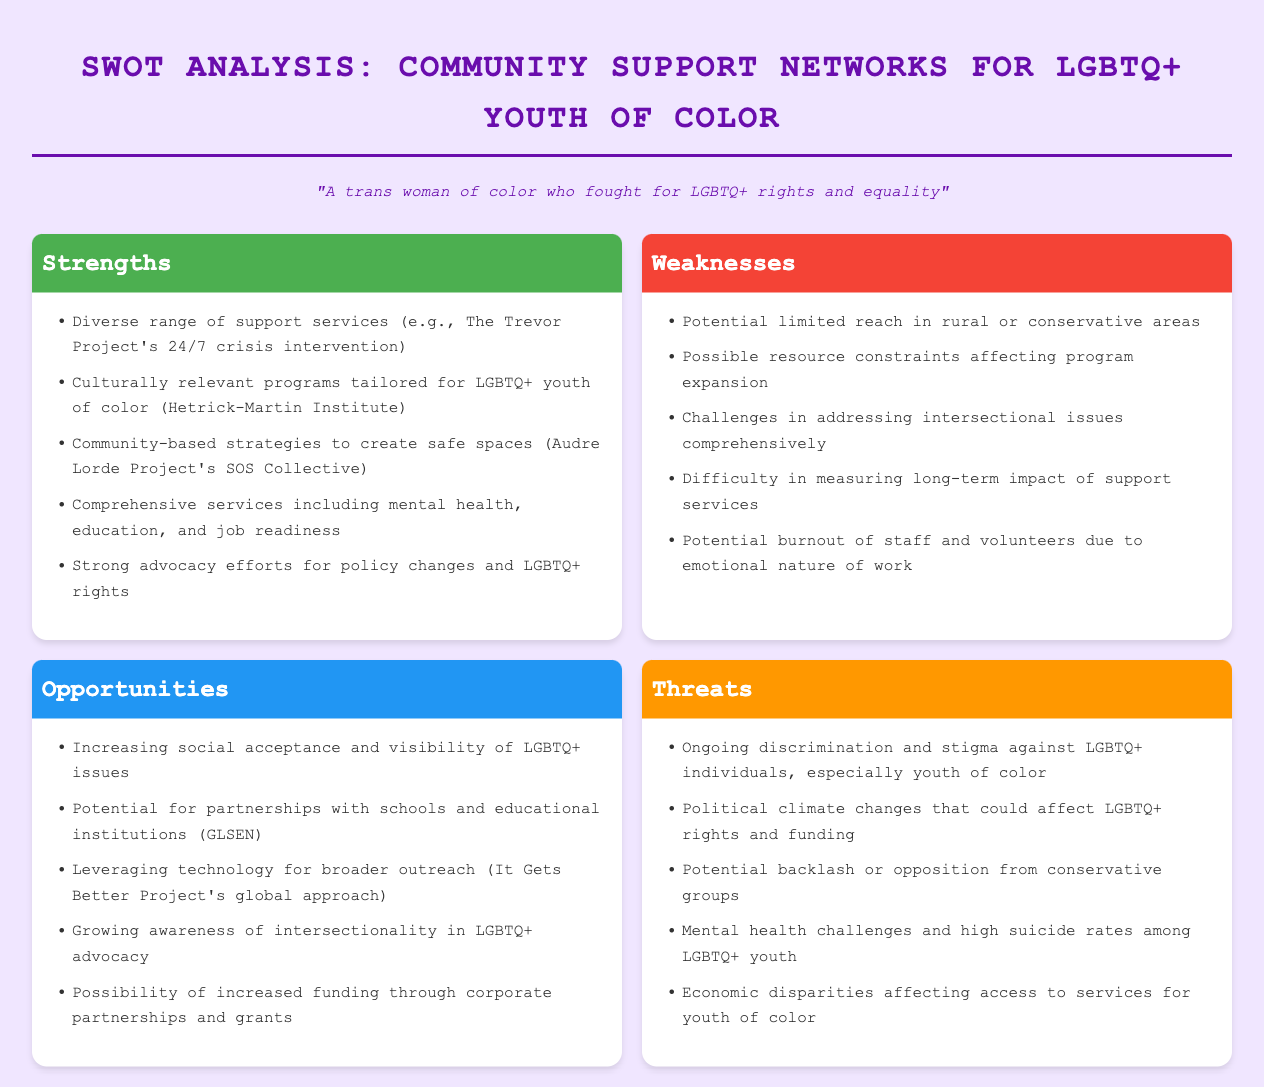What are some strengths of the community support networks? The strengths are outlined in the "Strengths" section and include diverse support services, culturally relevant programs, community-based strategies, comprehensive services, and strong advocacy efforts.
Answer: Diverse range of support services, culturally relevant programs, community-based strategies, comprehensive services, strong advocacy efforts What is a weakness related to program expansion? The weakness that affects program expansion can be found in the "Weaknesses" section, which mentions resource constraints.
Answer: Possible resource constraints affecting program expansion How can technology be leveraged for outreach? The "Opportunities" section suggests leveraging technology for broader outreach, which points towards modern strategies applicable for increasing visibility and access.
Answer: Leveraging technology for broader outreach What threat is related to mental health? The "Threats" section highlights multiple issues related to mental health, particularly among youth, indicating urgency in support measures.
Answer: Mental health challenges and high suicide rates among LGBTQ+ youth Which organization is mentioned for diverse support services? In the "Strengths" section, The Trevor Project is identified as providing a specific support service for youth, outlining its importance in crisis situations.
Answer: The Trevor Project's 24/7 crisis intervention What is a potential opportunity involving schools? The "Opportunities" section discusses the potential for partnerships that can facilitate interactions and support between community networks and educational institutions, thereby enhancing outreach.
Answer: Potential for partnerships with schools and educational institutions How do ongoing discrimination and stigma pose a threat? The "Threats" section states that discrimination against LGBTQ+ individuals, particularly youth of color, remains a significant issue impacting their well-being and support needs.
Answer: Ongoing discrimination and stigma against LGBTQ+ individuals, especially youth of color What program is highlighted for culturally relevant initiatives? Hetrick-Martin Institute is cited as an example of a program providing culturally relevant programming tailored for LGBTQ+ youth of color in the "Strengths" section.
Answer: Hetrick-Martin Institute 